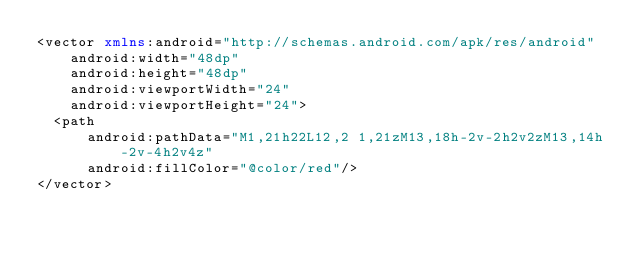Convert code to text. <code><loc_0><loc_0><loc_500><loc_500><_XML_><vector xmlns:android="http://schemas.android.com/apk/res/android"
    android:width="48dp"
    android:height="48dp"
    android:viewportWidth="24"
    android:viewportHeight="24">
  <path
      android:pathData="M1,21h22L12,2 1,21zM13,18h-2v-2h2v2zM13,14h-2v-4h2v4z"
      android:fillColor="@color/red"/>
</vector>
</code> 